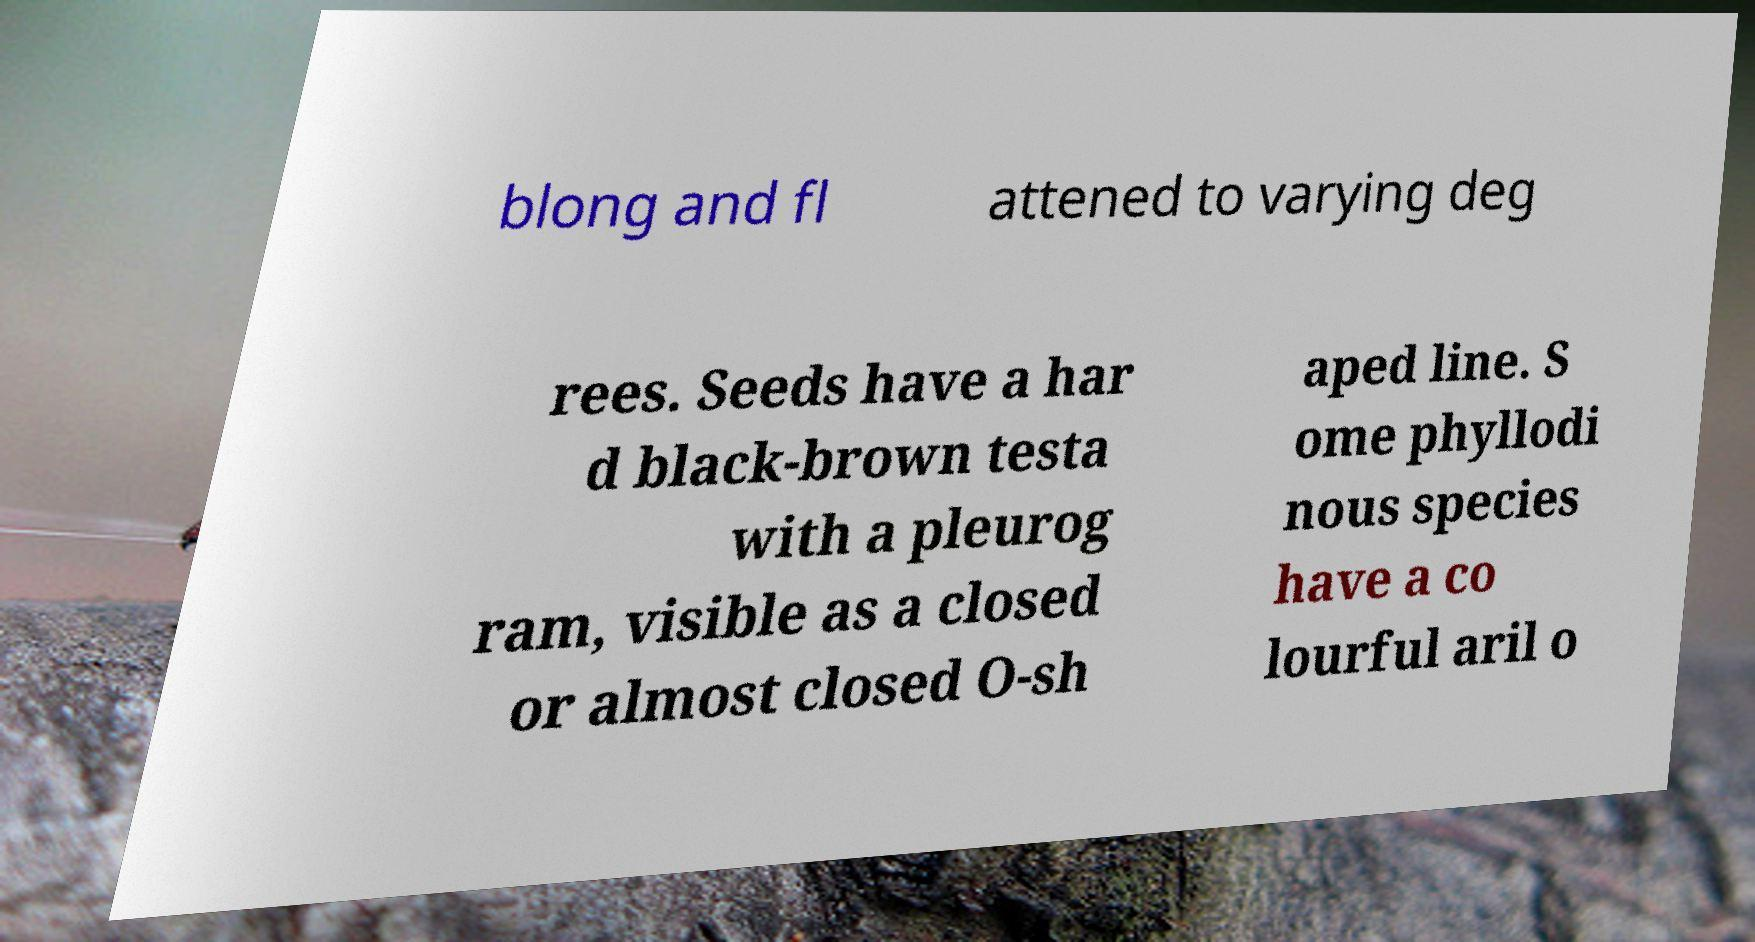For documentation purposes, I need the text within this image transcribed. Could you provide that? blong and fl attened to varying deg rees. Seeds have a har d black-brown testa with a pleurog ram, visible as a closed or almost closed O-sh aped line. S ome phyllodi nous species have a co lourful aril o 